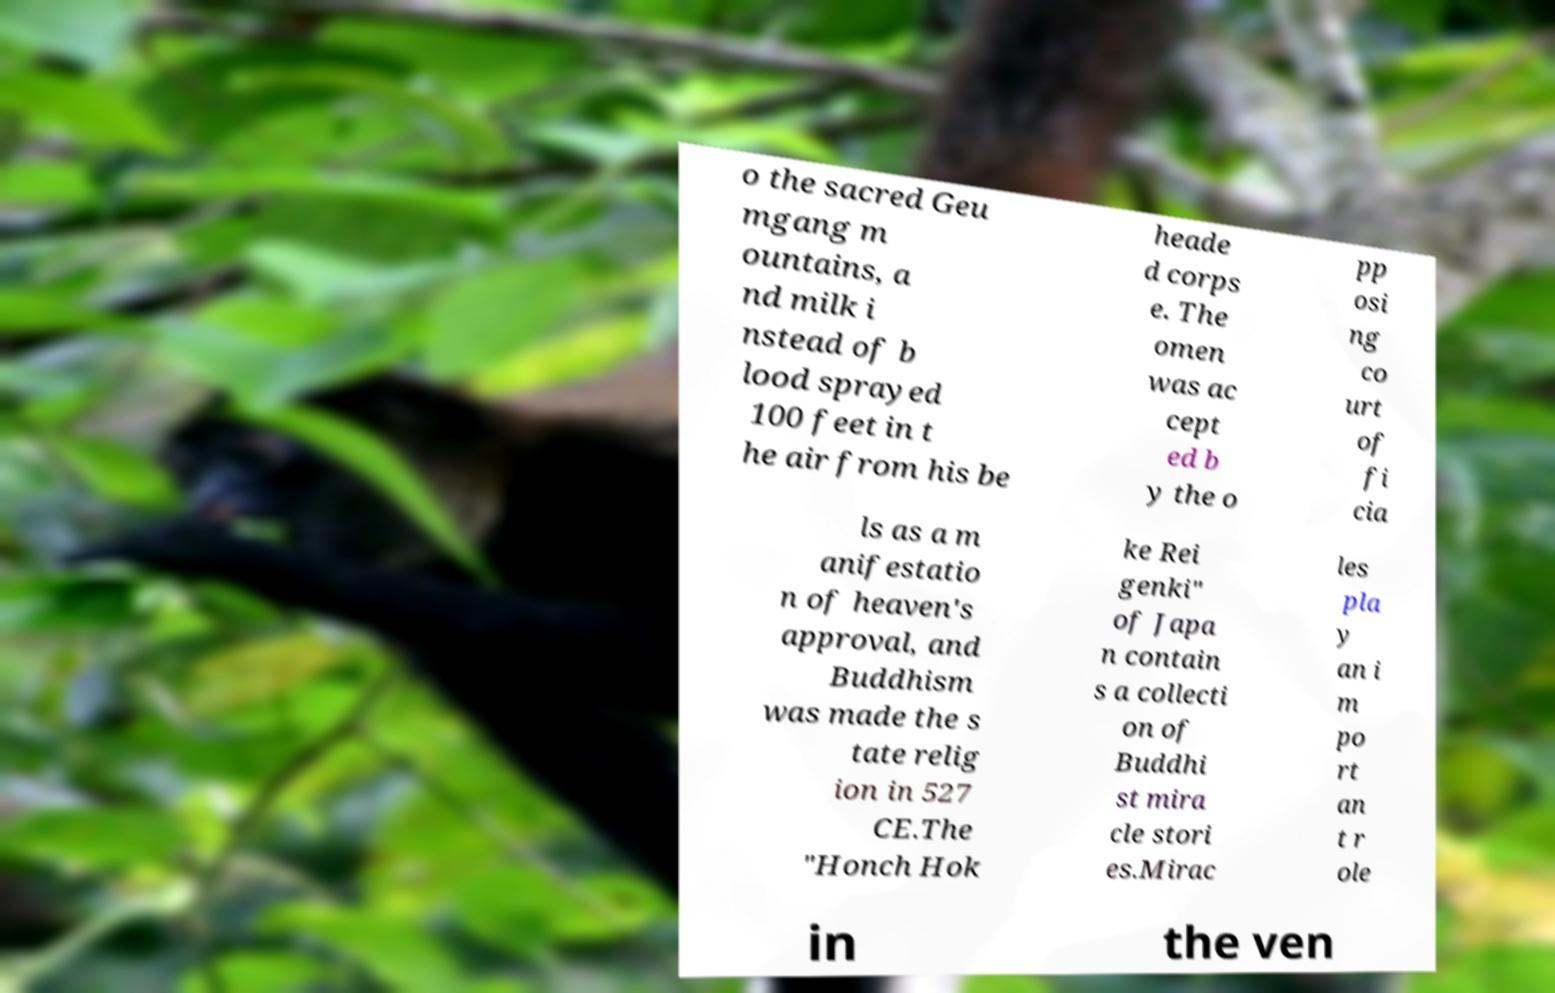Could you assist in decoding the text presented in this image and type it out clearly? o the sacred Geu mgang m ountains, a nd milk i nstead of b lood sprayed 100 feet in t he air from his be heade d corps e. The omen was ac cept ed b y the o pp osi ng co urt of fi cia ls as a m anifestatio n of heaven's approval, and Buddhism was made the s tate relig ion in 527 CE.The "Honch Hok ke Rei genki" of Japa n contain s a collecti on of Buddhi st mira cle stori es.Mirac les pla y an i m po rt an t r ole in the ven 